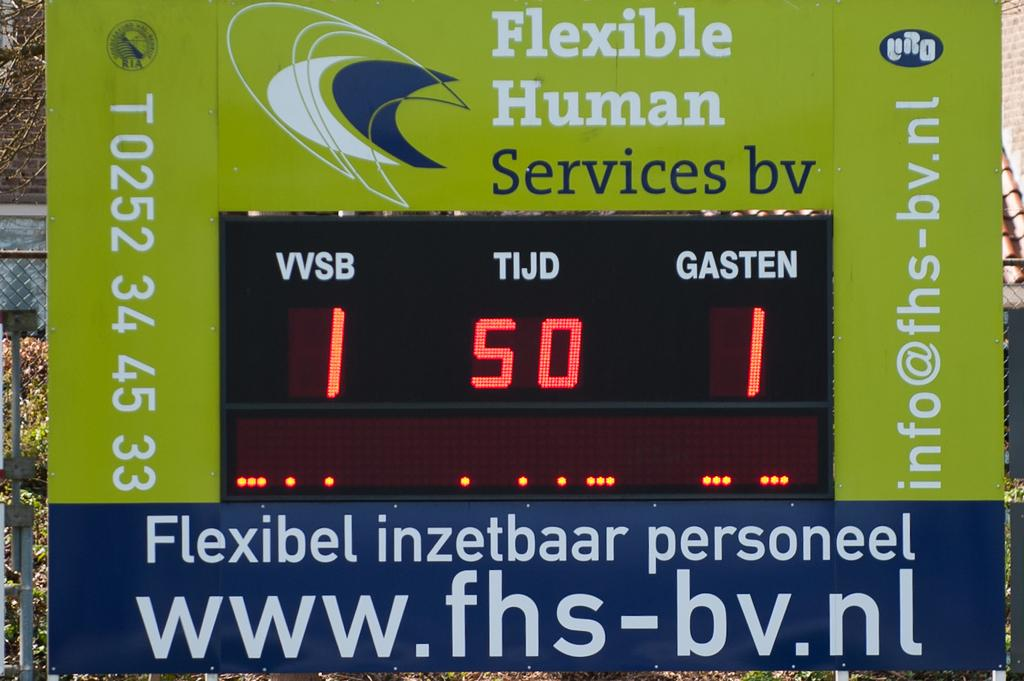<image>
Write a terse but informative summary of the picture. A tied game of 1 to 1 displayed on the flexible human services dashboard. 